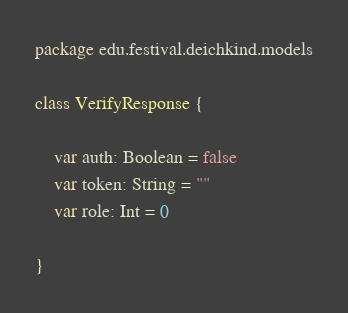<code> <loc_0><loc_0><loc_500><loc_500><_Kotlin_>package edu.festival.deichkind.models

class VerifyResponse {

    var auth: Boolean = false
    var token: String = ""
    var role: Int = 0

}</code> 